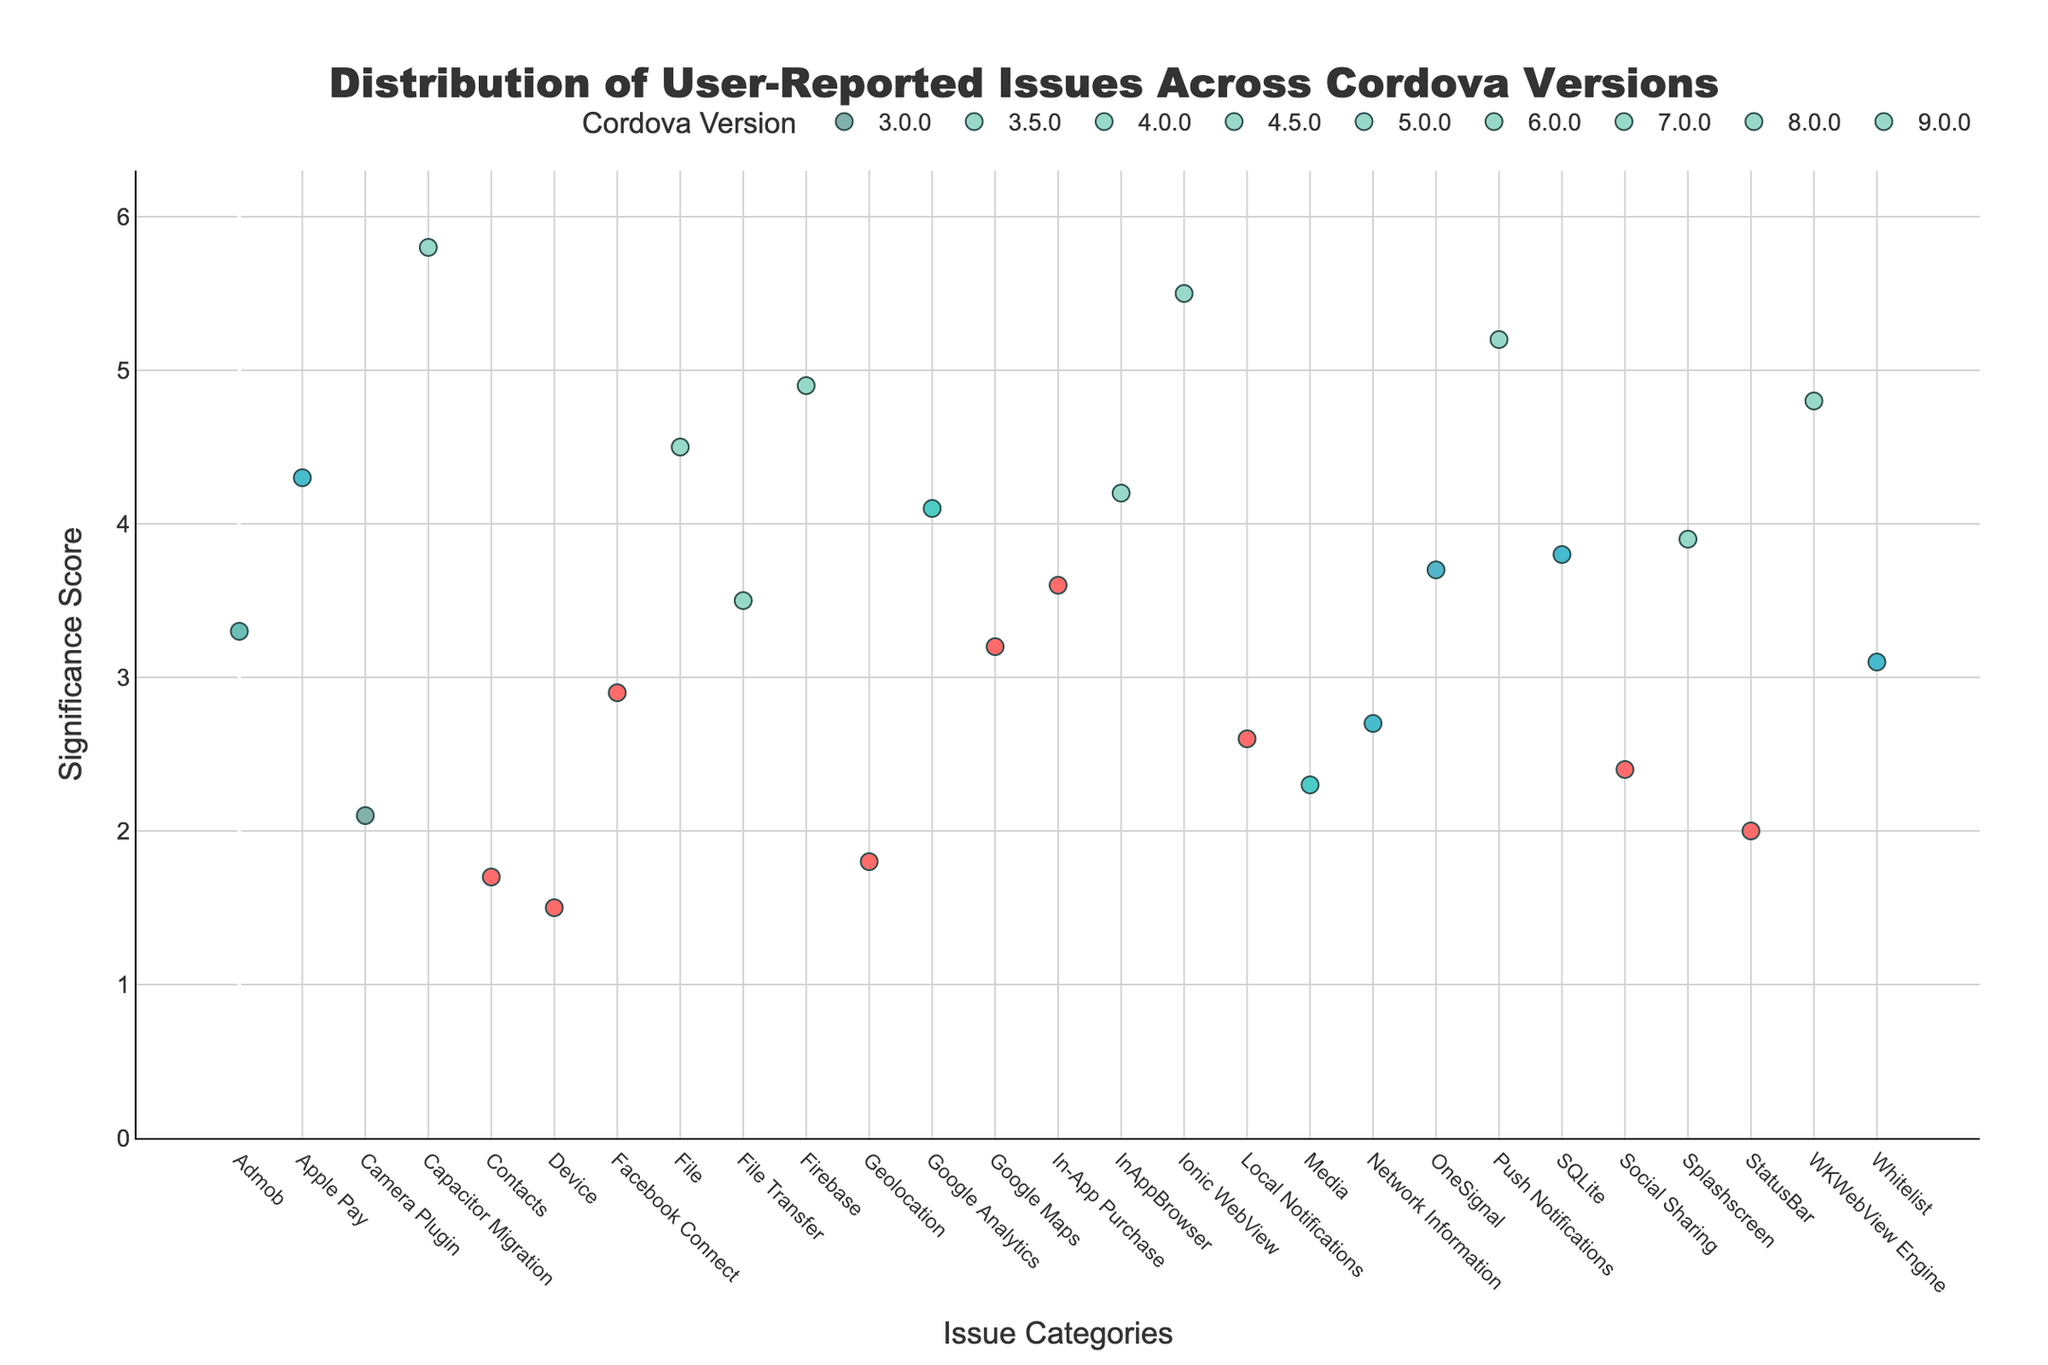How many issues were reported for Cordova version 5.0.0? To find the number of issues for Cordova version 5.0.0, look at the markers on the plot for version 5.0.0. Count the number of distinct markers.
Answer: 3 Which Cordova version has the highest significance score and in which issue category? To identify the highest significance score, find the data point with the maximum y-value. Then, note the version and issue category associated with this point based on the hover information.
Answer: 9.0.0, Capacitor Migration What is the significance score of the File Transfer issue in Cordova version 3.0.0? Locate the data point for Cordova version 3.0.0 and hover over the point corresponding to the File Transfer issue. The significance score will be displayed in the hover text.
Answer: 3.5 Compare the significance scores of Push Notifications in Cordova version 5.0.0 and Firebase in Cordova version 8.0.0. Which one is higher and by how much? Find the significance scores for Push Notifications and Firebase by hovering over their respective data points. Subtract the smaller score from the larger one to determine the difference.
Answer: Push Notifications is higher by 0.3 What is the average significance score of issues reported in Cordova version 7.0.0? Note the significance scores of all issues under 7.0.0. Sum these values and divide by the number of issues to get the average.
Answer: 4.4 Which Cordova version has the most number of reported issues? Count the number of data points for each Cordova version. The version with the highest count has the most reported issues.
Answer: 9.0.0 Which issue has a higher significance score: Network Information for version 3.5.0 or Google Analytics for version 7.0.0? Compare the y-values of Network Information for version 3.5.0 and Google Analytics for version 7.0.0. Determine which is higher.
Answer: Google Analytics Is there a version where all reported issues have a significance score above 3.0? For each version, check all its issues' significance scores. Identify if there is a version where each issue has a score higher than 3.0.
Answer: No (Not all issues in all versions have scores above 3.0) Which issue category appears to have the highest significance score for the earliest version listed in the plot? Identify the earliest version, then find the issue category with the highest y-value (significance score) for that version by hover info.
Answer: File Transfer 